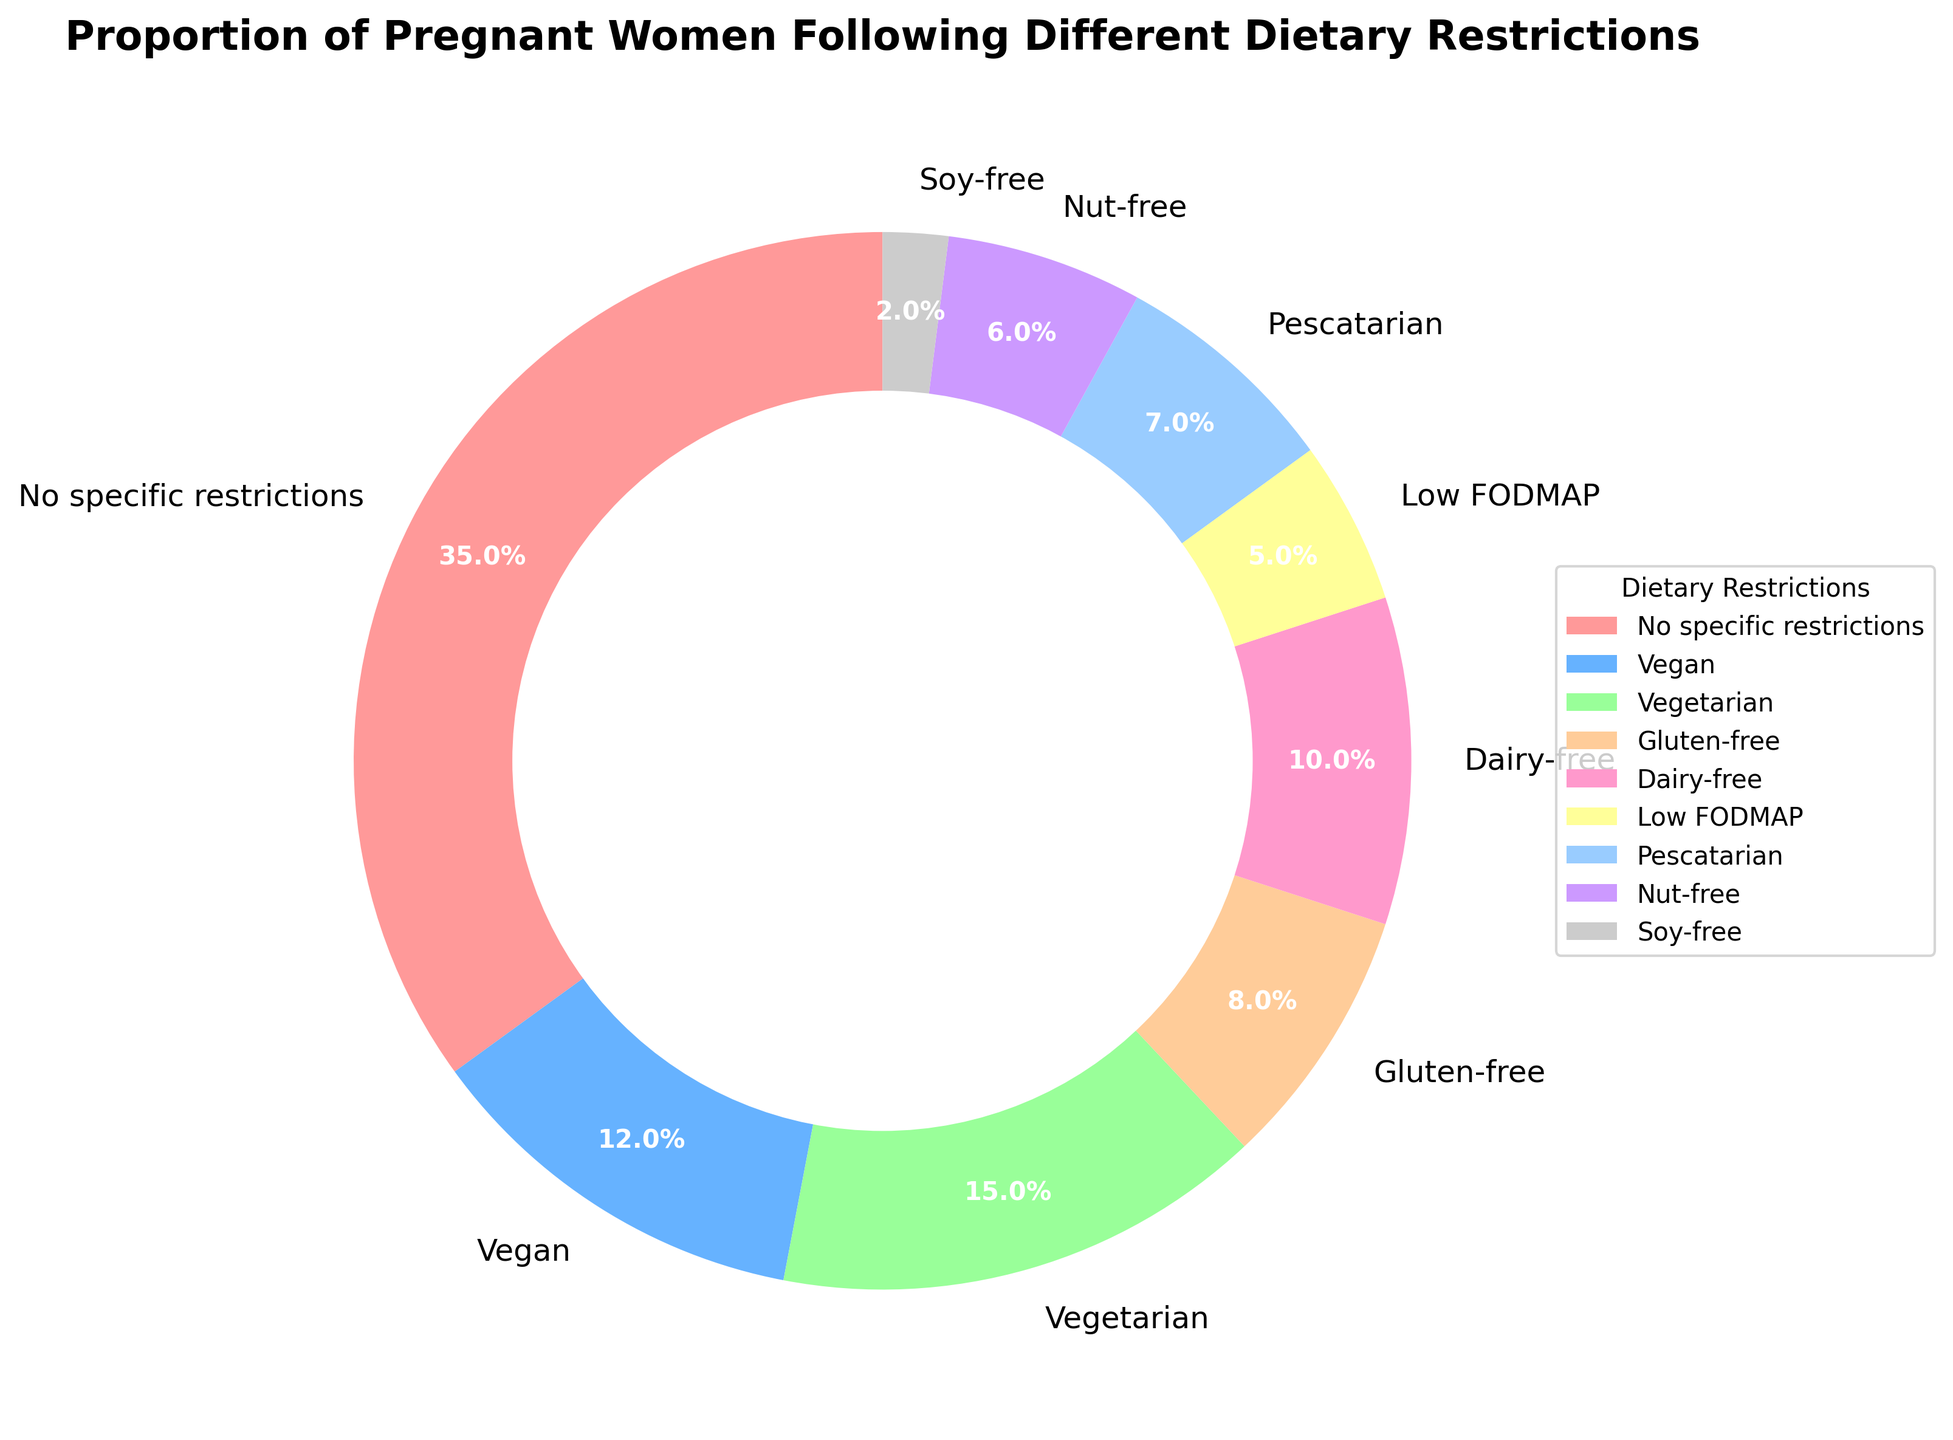What percentage of pregnant women follow a vegan diet? The pie chart displays the proportion of pregnant women adhering to different dietary restrictions. According to the chart, 12% of pregnant women follow a vegan diet.
Answer: 12% Which dietary restriction is the most common among pregnant women? By examining the sizes of the pie chart sections, the "No specific restrictions" section is the largest, indicating it is the most common dietary restriction among pregnant women.
Answer: No specific restrictions Compare the percentage of pregnant women following a gluten-free diet and those following a dairy-free diet. Which one is higher, and by how much? The chart shows that 8% of pregnant women follow a gluten-free diet and 10% follow a dairy-free diet. The dairy-free percentage is higher by 10% - 8% = 2%.
Answer: Dairy-free by 2% What proportion of pregnant women follow either a vegetarian or a pescatarian diet? Adding the percentages for vegetarian (15%) and pescatarian (7%) from the chart, the total proportion is 15% + 7% = 22%.
Answer: 22% How does the number of pregnant women following a nut-free diet compare to those following a soy-free diet? The chart indicates that 6% of pregnant women follow a nut-free diet, while 2% follow a soy-free diet. The nut-free percentage is higher by 6% - 2% = 4%.
Answer: Nut-free by 4% If we combine the percentages of pregnant women following vegan, vegetarian, and pescatarian diets, what is the total percentage? Adding the proportions for vegan (12%), vegetarian (15%), and pescatarian (7%), we get 12% + 15% + 7% = 34%.
Answer: 34% What colors represent the vegan and gluten-free diets in the pie chart? The vegan section is represented by a blue color, while the gluten-free section is shown in a green-yellow hue.
Answer: Blue for vegan, green-yellow for gluten-free Is the percentage of pregnant women following a low FODMAP diet less than, equal to, or greater than those following a pescatarian diet? The chart shows 5% for low FODMAP and 7% for pescatarian. Since 5% is less than 7%, the low FODMAP percentage is lesser.
Answer: Less than Which dietary restriction has the smallest proportion of followers among pregnant women? From the chart, the smallest segment corresponds to the soy-free category, which is 2%.
Answer: Soy-free What is the combined proportion of pregnant women following dairy-free, nut-free, and soy-free diets? Summing the percentages for dairy-free (10%), nut-free (6%), and soy-free (2%), the combined proportion is 10% + 6% + 2% = 18%.
Answer: 18% 